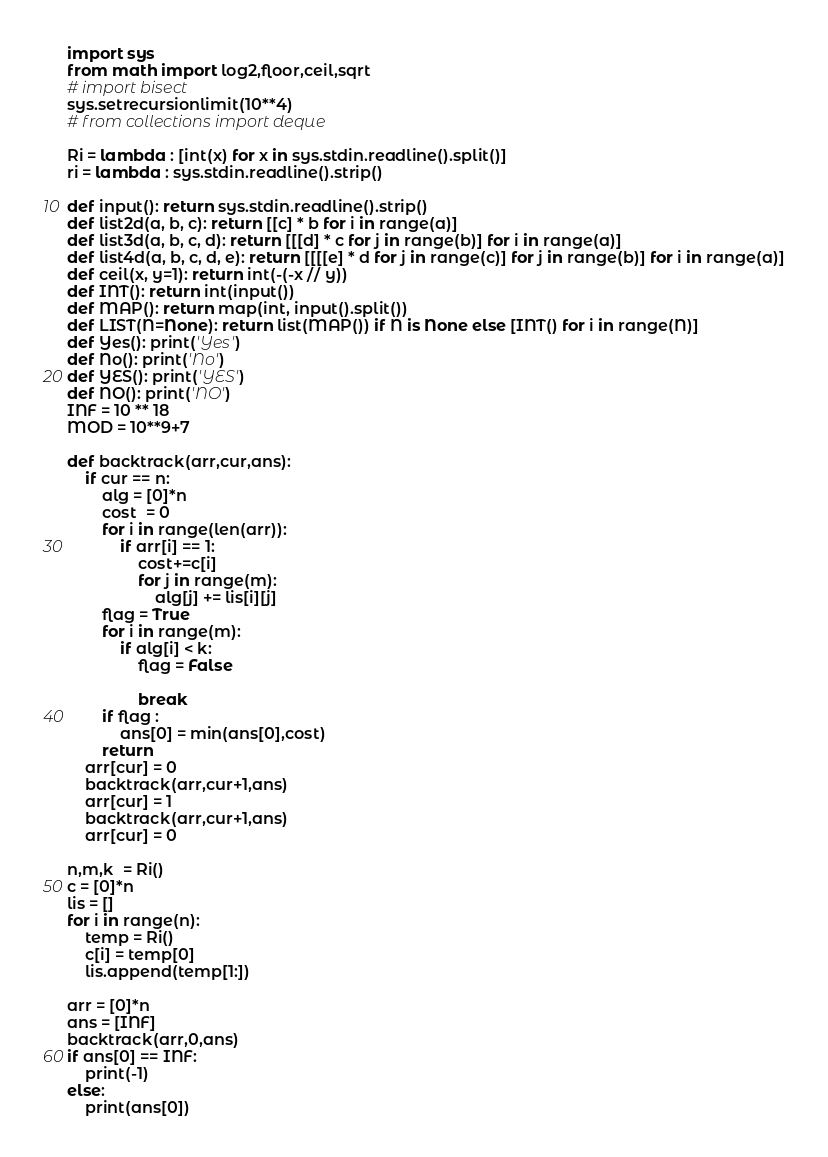<code> <loc_0><loc_0><loc_500><loc_500><_Python_>import sys
from math import log2,floor,ceil,sqrt
# import bisect
sys.setrecursionlimit(10**4)
# from collections import deque

Ri = lambda : [int(x) for x in sys.stdin.readline().split()]
ri = lambda : sys.stdin.readline().strip()
 
def input(): return sys.stdin.readline().strip()
def list2d(a, b, c): return [[c] * b for i in range(a)]
def list3d(a, b, c, d): return [[[d] * c for j in range(b)] for i in range(a)]
def list4d(a, b, c, d, e): return [[[[e] * d for j in range(c)] for j in range(b)] for i in range(a)]
def ceil(x, y=1): return int(-(-x // y))
def INT(): return int(input())
def MAP(): return map(int, input().split())
def LIST(N=None): return list(MAP()) if N is None else [INT() for i in range(N)]
def Yes(): print('Yes')
def No(): print('No')
def YES(): print('YES')
def NO(): print('NO')
INF = 10 ** 18
MOD = 10**9+7

def backtrack(arr,cur,ans):
    if cur == n:
        alg = [0]*n
        cost  = 0
        for i in range(len(arr)):
            if arr[i] == 1:
                cost+=c[i]
                for j in range(m):
                    alg[j] += lis[i][j]
        flag = True
        for i in range(m):
            if alg[i] < k:
                flag = False

                break
        if flag :
            ans[0] = min(ans[0],cost)
        return
    arr[cur] = 0
    backtrack(arr,cur+1,ans)
    arr[cur] = 1
    backtrack(arr,cur+1,ans)
    arr[cur] = 0

n,m,k  = Ri()
c = [0]*n
lis = []
for i in range(n):
    temp = Ri()
    c[i] = temp[0]
    lis.append(temp[1:])

arr = [0]*n
ans = [INF]
backtrack(arr,0,ans)
if ans[0] == INF:
    print(-1)
else:
    print(ans[0])</code> 